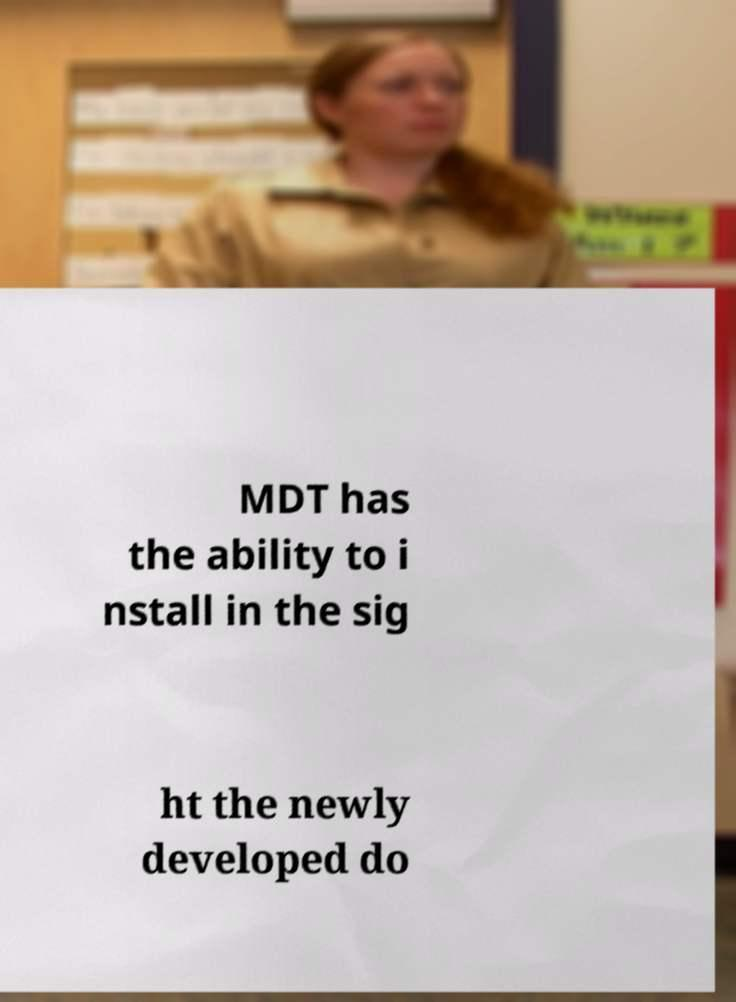I need the written content from this picture converted into text. Can you do that? MDT has the ability to i nstall in the sig ht the newly developed do 